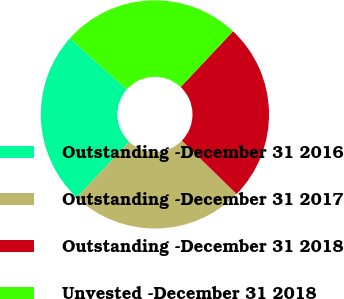<chart> <loc_0><loc_0><loc_500><loc_500><pie_chart><fcel>Outstanding -December 31 2016<fcel>Outstanding -December 31 2017<fcel>Outstanding -December 31 2018<fcel>Unvested -December 31 2018<nl><fcel>24.61%<fcel>24.71%<fcel>25.29%<fcel>25.39%<nl></chart> 